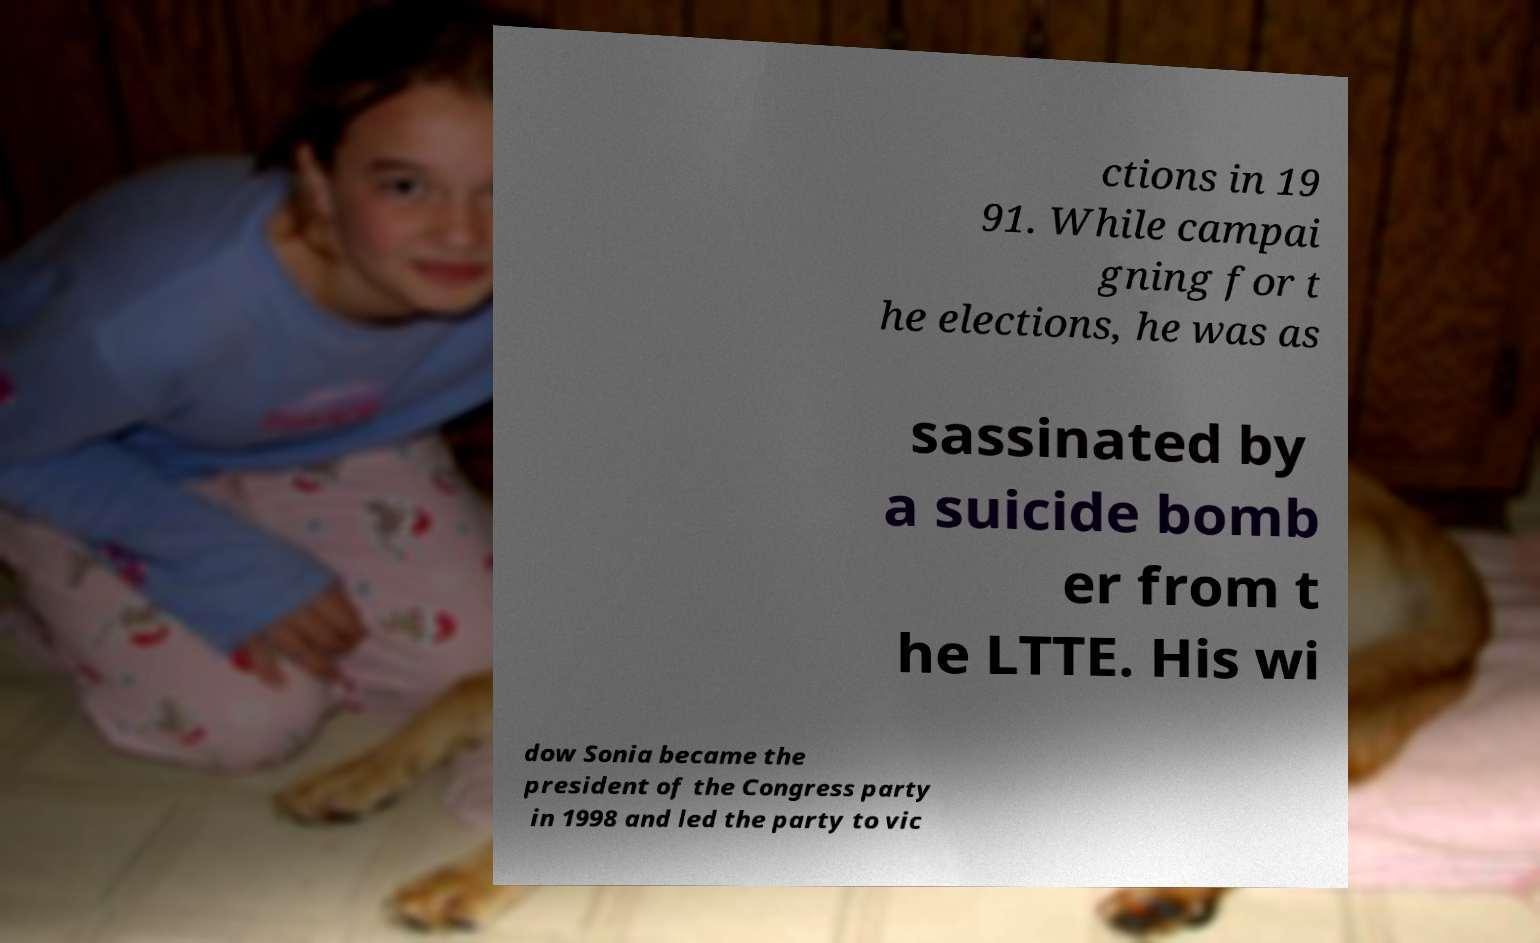There's text embedded in this image that I need extracted. Can you transcribe it verbatim? ctions in 19 91. While campai gning for t he elections, he was as sassinated by a suicide bomb er from t he LTTE. His wi dow Sonia became the president of the Congress party in 1998 and led the party to vic 